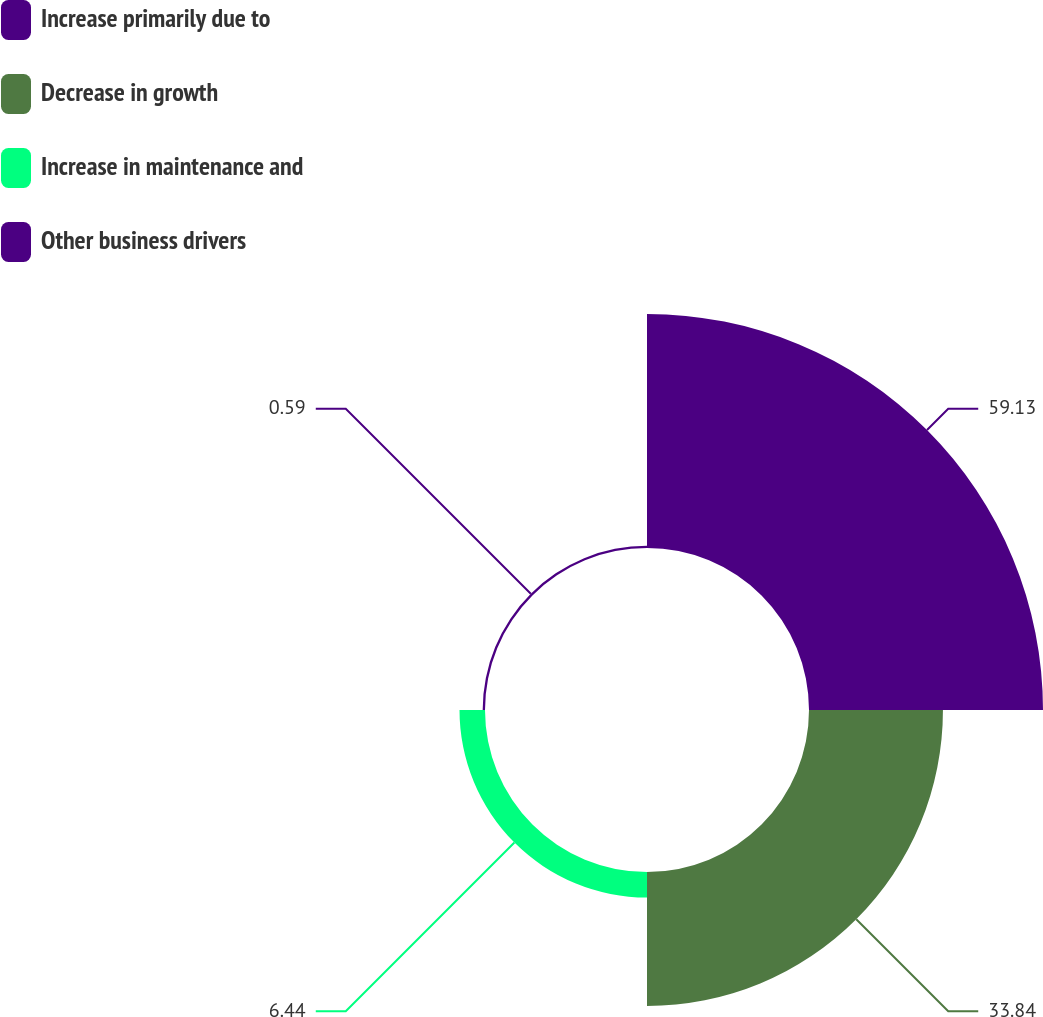<chart> <loc_0><loc_0><loc_500><loc_500><pie_chart><fcel>Increase primarily due to<fcel>Decrease in growth<fcel>Increase in maintenance and<fcel>Other business drivers<nl><fcel>59.12%<fcel>33.84%<fcel>6.44%<fcel>0.59%<nl></chart> 